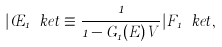Convert formula to latex. <formula><loc_0><loc_0><loc_500><loc_500>| \phi _ { 1 } \ k e t \equiv \frac { 1 } { 1 - G _ { 1 } ( E ) V } | F _ { 1 } \ k e t ,</formula> 